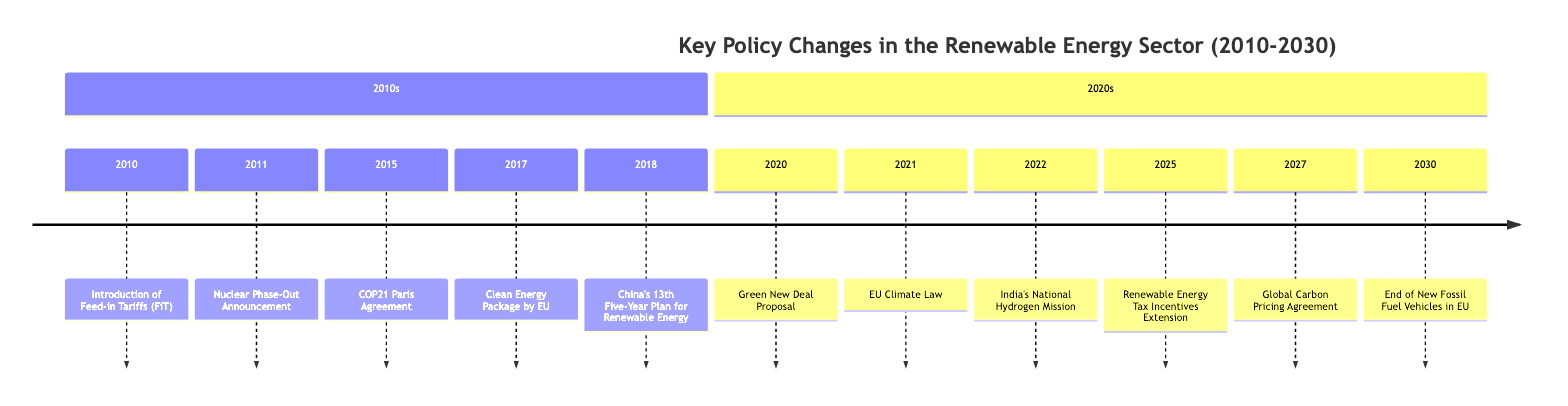What event introduced Feed-in Tariffs? According to the diagram, the event that introduced Feed-in Tariffs occurred in 2010 and is labeled as "Introduction of Feed-in Tariffs (FiT)."
Answer: Introduction of Feed-in Tariffs (FiT) How many key policy changes occurred in the 2010s? By counting the events listed in the timeline segment for the 2010s, we see five distinct events (2010, 2011, 2015, 2017, 2018).
Answer: 5 What year did the COP21 Paris Agreement take place? The timeline indicates that the COP21 Paris Agreement event is marked in the year 2015.
Answer: 2015 Which country's plan sets ambitious renewable energy targets in 2018? The diagram shows that in 2018, China's 13th Five-Year Plan for Renewable Energy was highlighted, indicating China's involvement in setting targets.
Answer: China What policy change happened in 2021? The event that occurred in 2021, as per the timeline, is the "EU Climate Law."
Answer: EU Climate Law What is the event occurring just before the Global Carbon Pricing Agreement? According to the timeline, the event that occurs just before the Global Carbon Pricing Agreement in 2027 is the "Renewable Energy Tax Incentives Extension" in 2025.
Answer: Renewable Energy Tax Incentives Extension How many events are listed for the year 2020 and later? In analyzing the timeline, we count six distinct events from the year 2020 to 2030, as listed: 2020, 2021, 2022, 2025, 2027, and 2030.
Answer: 6 What is the last event listed on the timeline? The timeline indicates that the last event listed occurs in 2030, which is "End of New Fossil Fuel Vehicles in EU."
Answer: End of New Fossil Fuel Vehicles in EU Which region is associated with the "Clean Energy Package" enacted in 2017? In the timeline, the "Clean Energy Package" is associated with the EU, as indicated directly next to the event in 2017.
Answer: EU What long-term goal did the EU Climate Law in 2021 establish? The diagram notes that the EU Climate Law established climate neutrality by 2050, completing the longer-term objectives set for member states.
Answer: Climate neutrality by 2050 